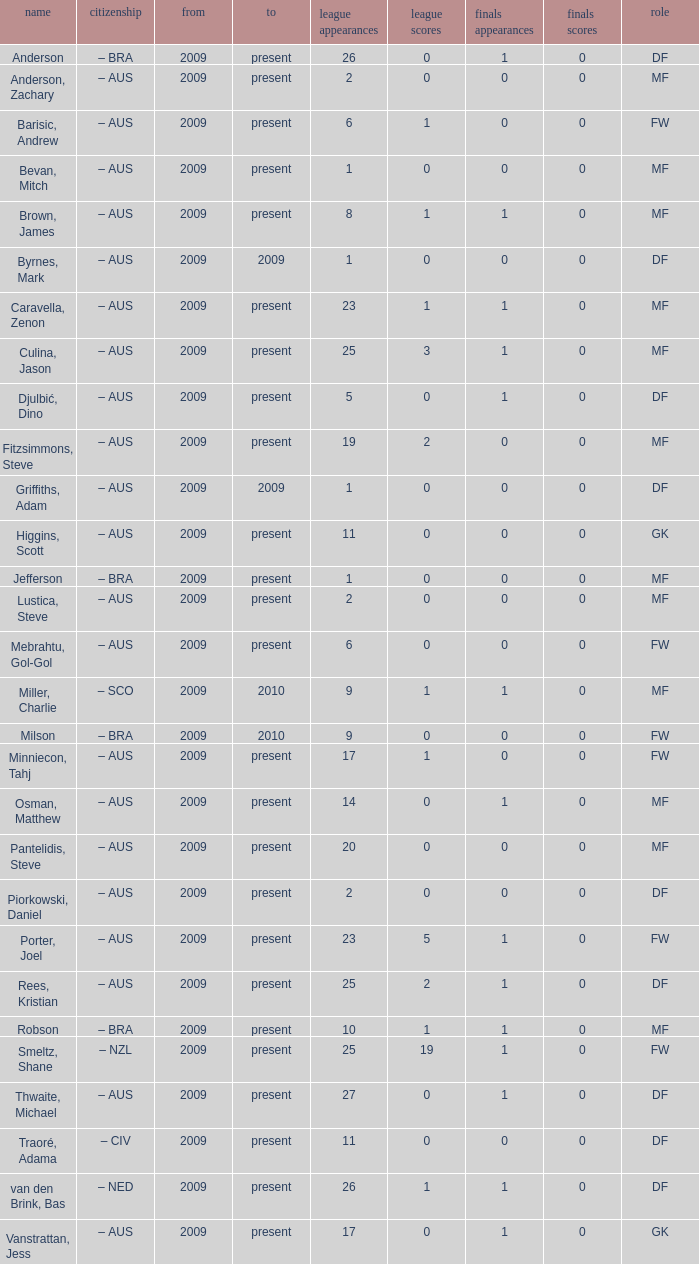Name the position for van den brink, bas DF. 